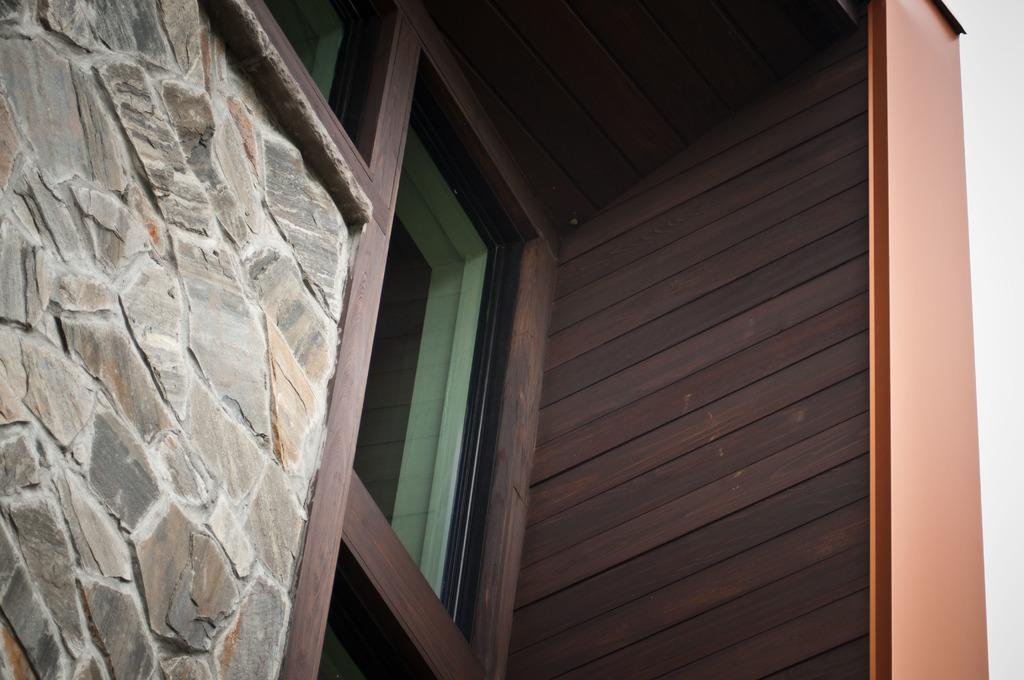What type of structures can be seen in the image? There are walls in the image. Is there any opening in the walls? Yes, there is a window in the image. What type of objects are made of glass in the image? There are glass objects in the image. What type of soda is being served in the glass objects in the image? There is no soda present in the image; it only features walls, a window, and glass objects. 